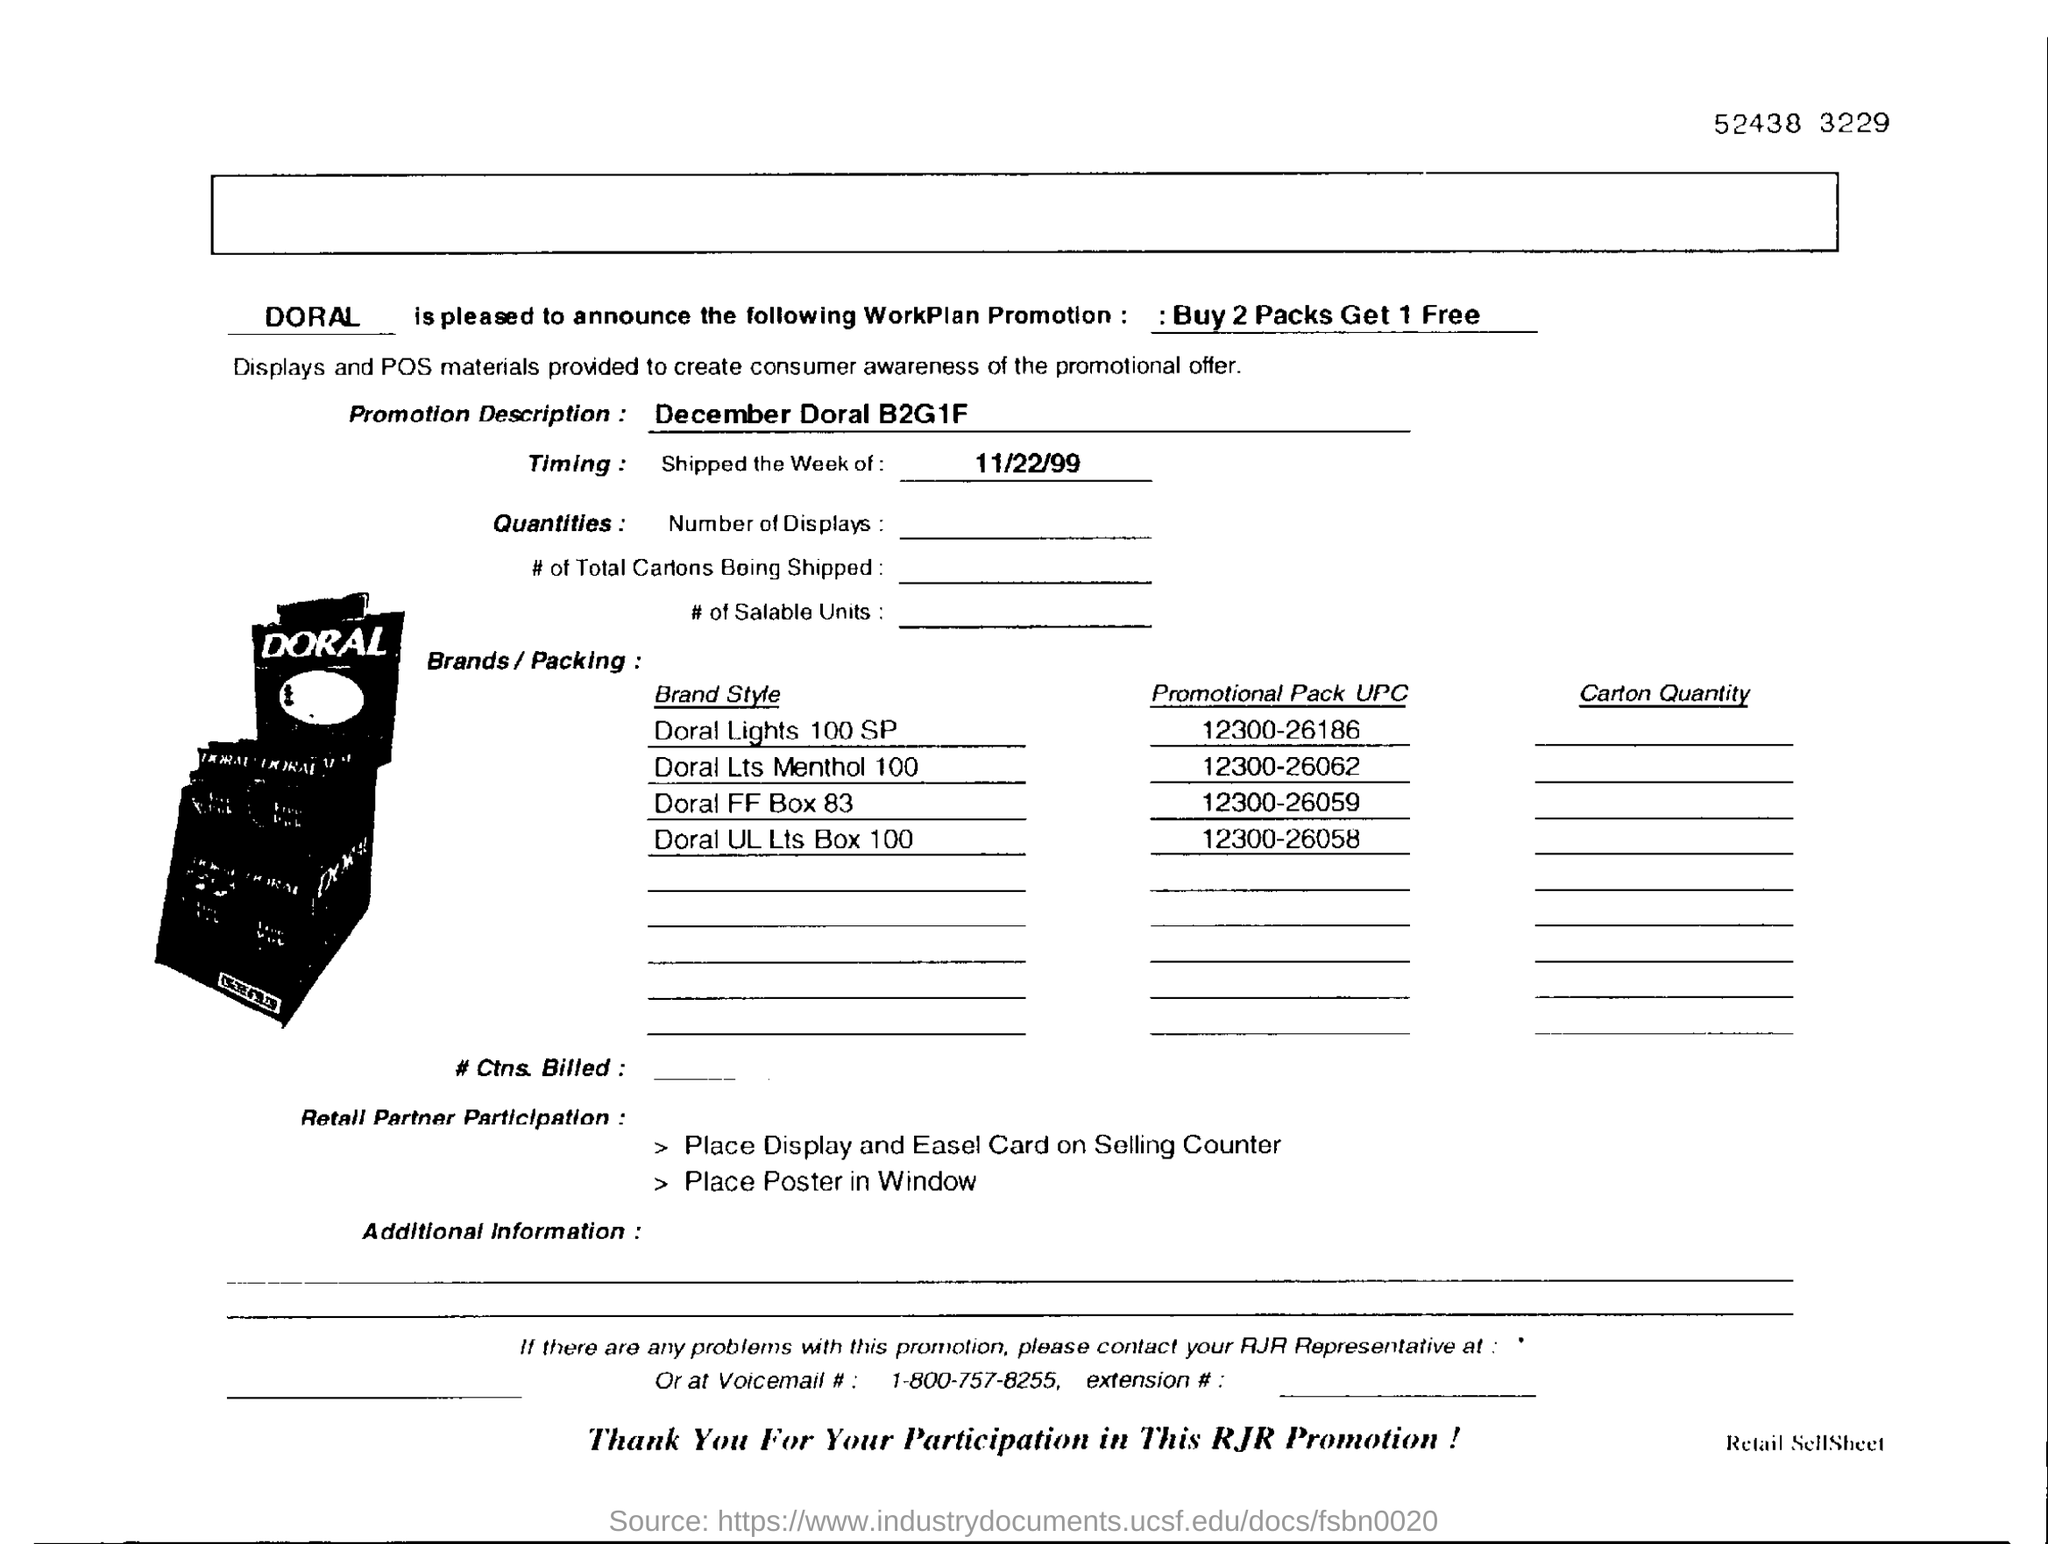Give some essential details in this illustration. The "WorkPlan Promotion" offers a discount of one free pack for every two packs purchased. The UPC number for Doral FF Box 83 is 12300-26059. The identity of the brand "Doral" is unknown. What is the Promotion Description? For the month of December in Doral, buy one get one free and buy two get three free are the promotional offers. 